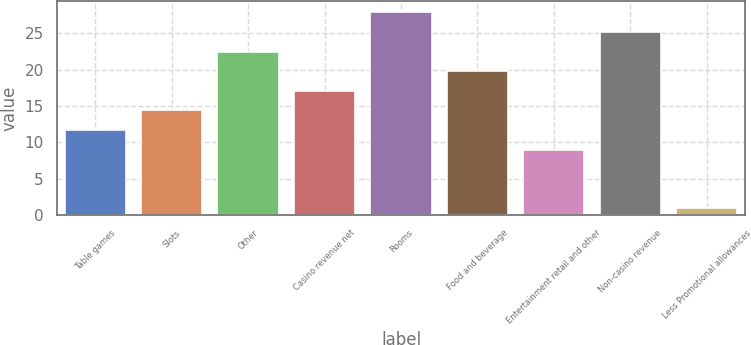Convert chart. <chart><loc_0><loc_0><loc_500><loc_500><bar_chart><fcel>Table games<fcel>Slots<fcel>Other<fcel>Casino revenue net<fcel>Rooms<fcel>Food and beverage<fcel>Entertainment retail and other<fcel>Non-casino revenue<fcel>Less Promotional allowances<nl><fcel>11.7<fcel>14.4<fcel>22.5<fcel>17.1<fcel>28<fcel>19.8<fcel>9<fcel>25.2<fcel>1<nl></chart> 